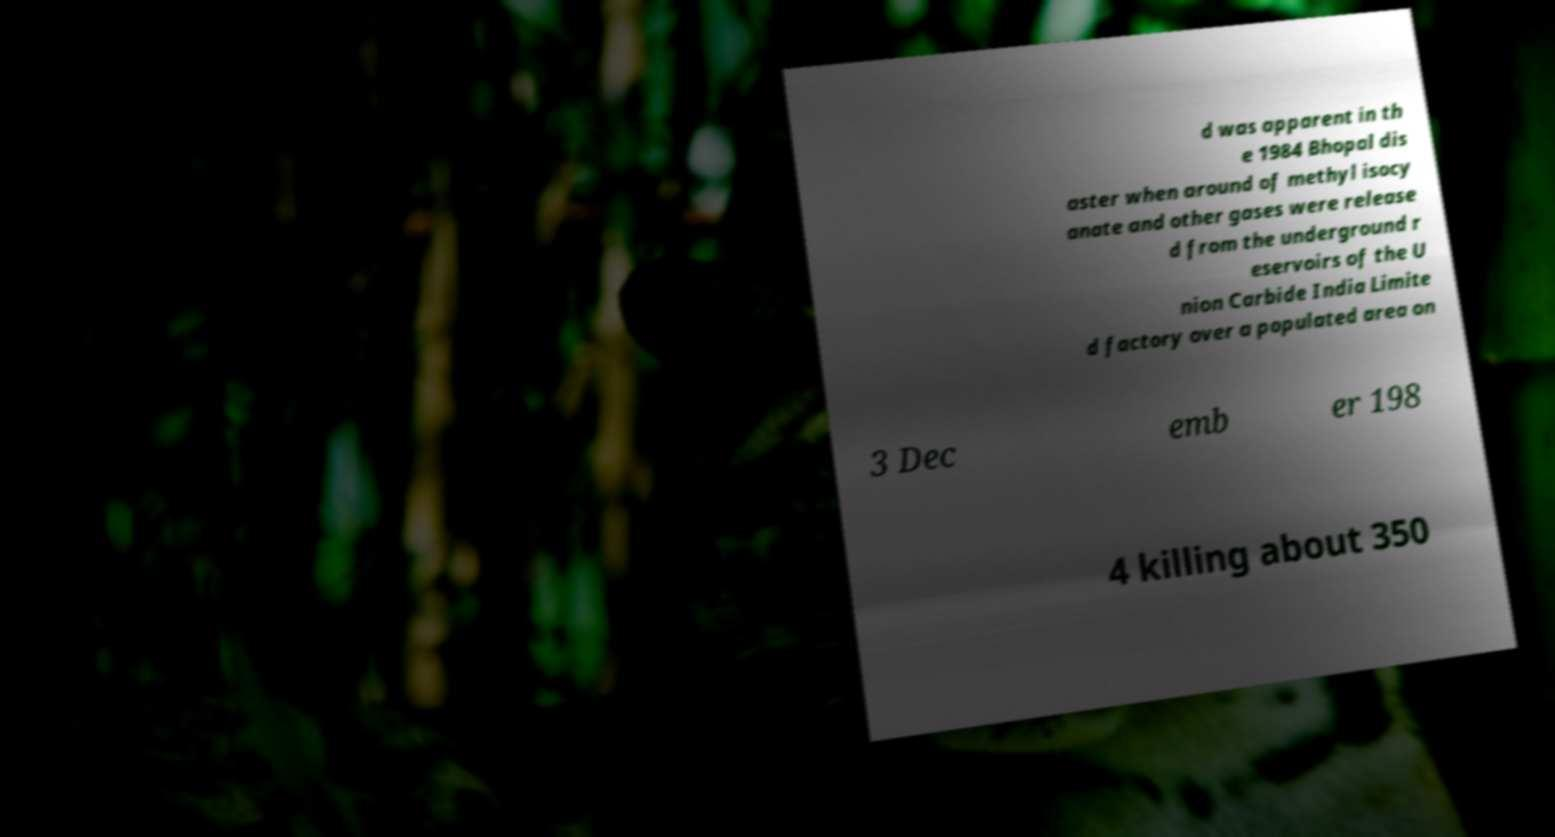Please identify and transcribe the text found in this image. d was apparent in th e 1984 Bhopal dis aster when around of methyl isocy anate and other gases were release d from the underground r eservoirs of the U nion Carbide India Limite d factory over a populated area on 3 Dec emb er 198 4 killing about 350 